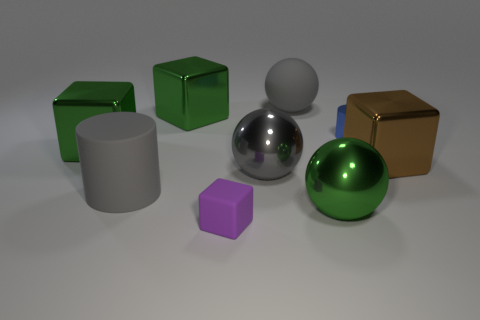How big is the matte thing behind the big brown cube?
Ensure brevity in your answer.  Large. What size is the gray metal object that is to the left of the large brown cube that is on the right side of the large green thing that is in front of the large matte cylinder?
Offer a terse response. Large. What color is the big matte object that is right of the gray ball that is in front of the blue metal thing?
Your answer should be compact. Gray. What material is the purple thing that is the same shape as the brown metallic object?
Offer a very short reply. Rubber. Is there anything else that is the same material as the gray cylinder?
Keep it short and to the point. Yes. There is a big gray cylinder; are there any large gray matte spheres to the right of it?
Keep it short and to the point. Yes. What number of cubes are there?
Your answer should be very brief. 4. There is a gray object that is behind the blue metal thing; what number of gray things are on the left side of it?
Ensure brevity in your answer.  2. Do the matte block and the rubber thing behind the brown shiny thing have the same color?
Provide a short and direct response. No. How many other rubber objects are the same shape as the tiny purple thing?
Provide a succinct answer. 0. 